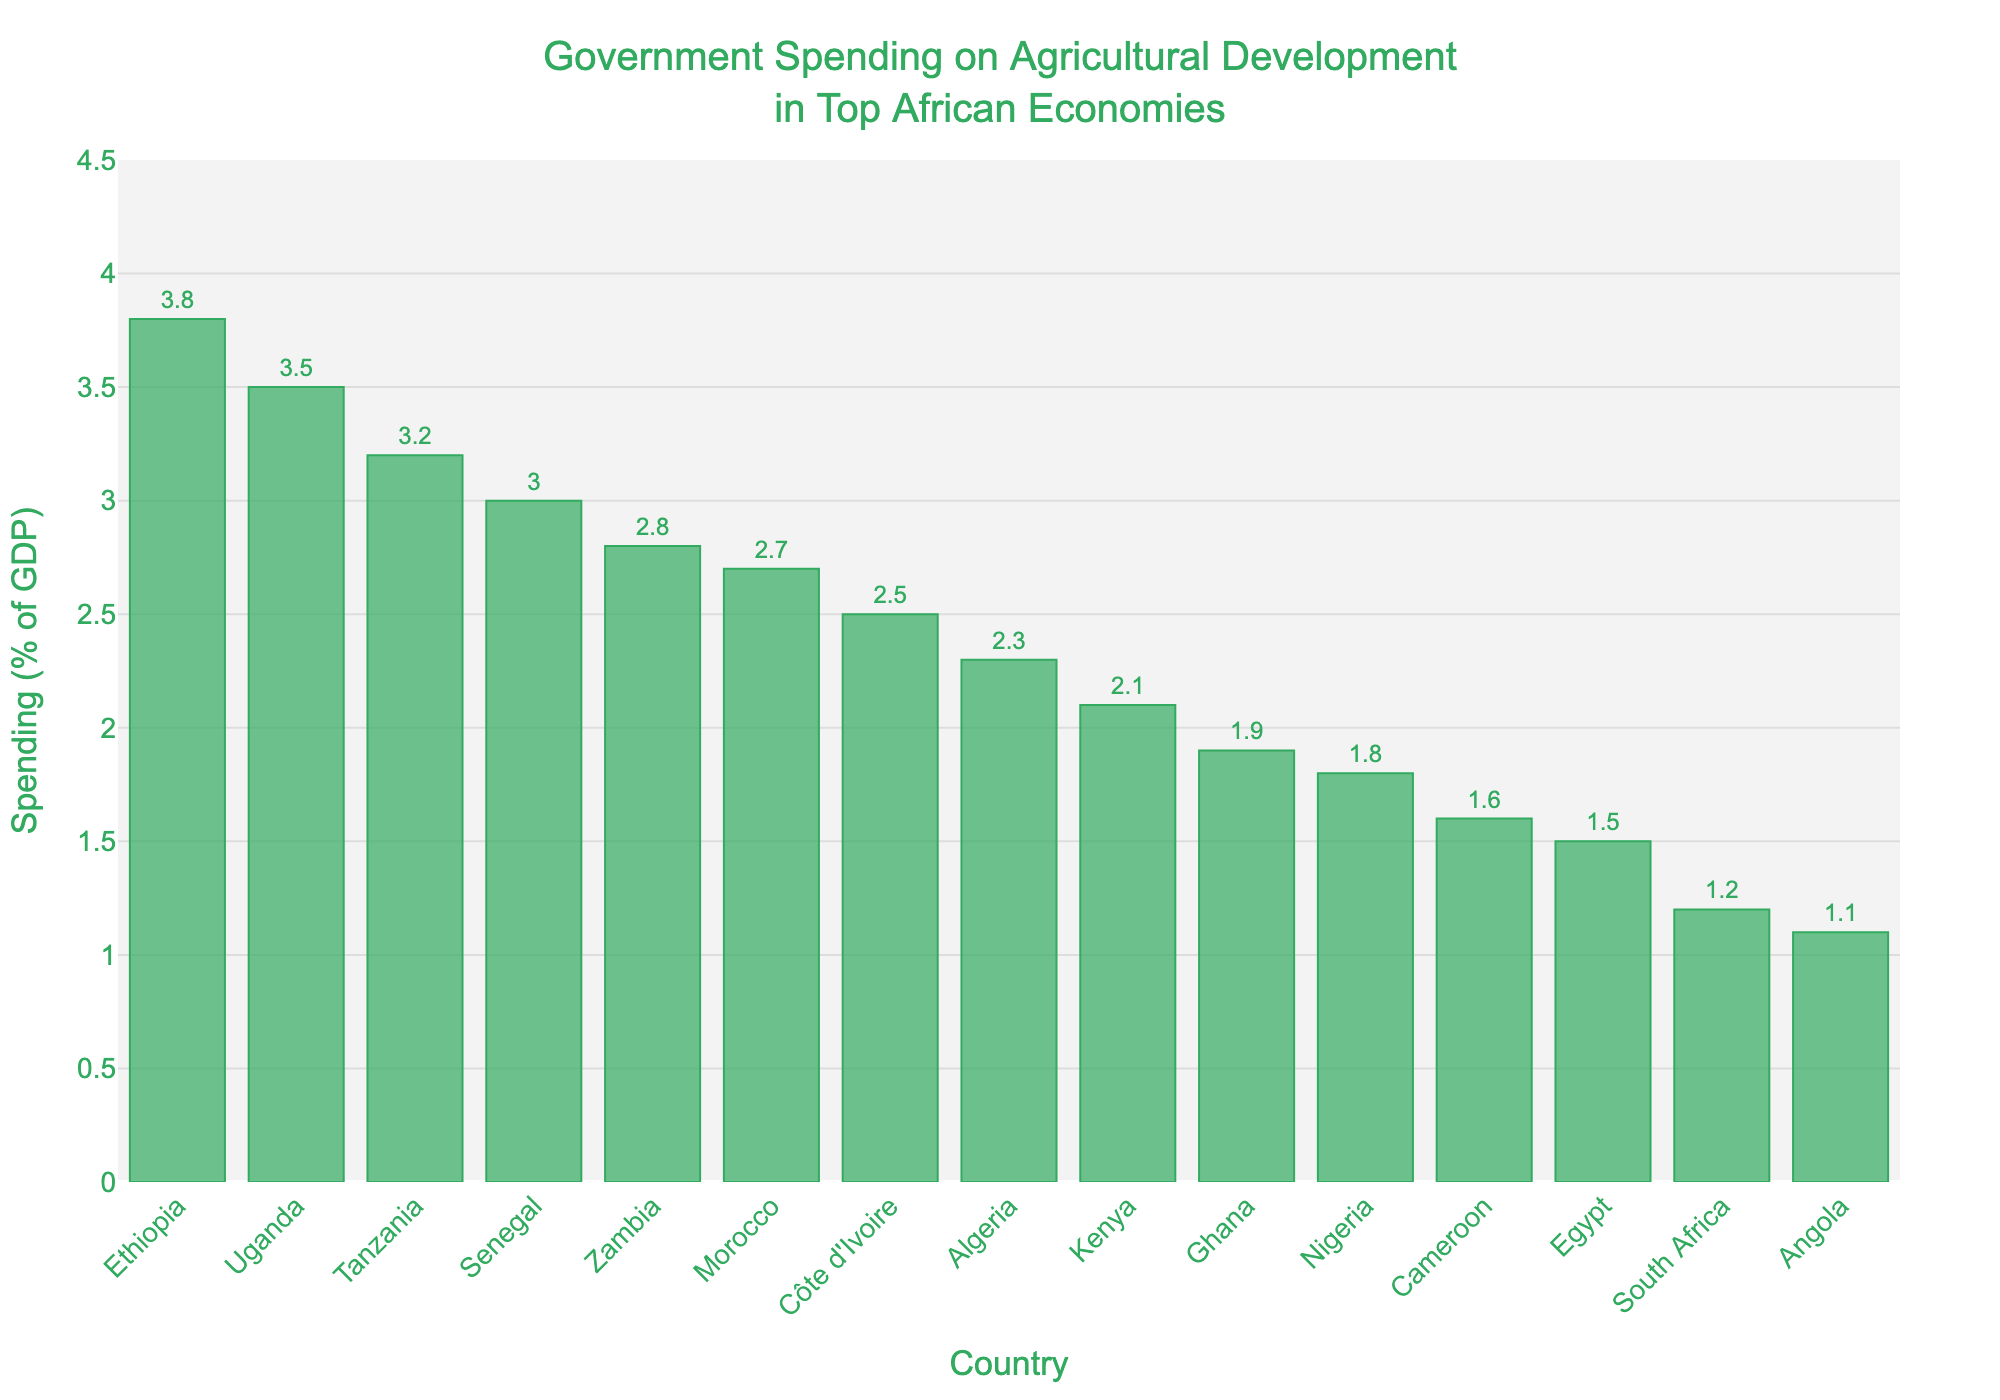Which country has the highest government spending on agricultural development as a percentage of GDP? Ethiopia has the tallest bar in the chart, indicating the highest percentage of GDP spent on agricultural development.
Answer: Ethiopia Which country spends the least on agricultural development as a percentage of GDP? Angola has the shortest bar, indicating the lowest percentage of GDP spent on agricultural development.
Answer: Angola By how much does Ethiopia's spending exceed that of Nigeria? Ethiopia's spending is 3.8% and Nigeria's is 1.8%. The difference is 3.8% - 1.8%.
Answer: 2.0% What is the average government spending on agricultural development for the countries shown? Sum all percentages (1.8 + 1.2 + 1.5 + 2.3 + 2.7 + 2.1 + 3.8 + 1.9 + 3.2 + 2.5 + 3.5 + 1.6 + 2.8 + 1.1 + 3.0) = 35.9. Divide by the number of countries: 35.9 / 15.
Answer: 2.39% How many countries have a government spending of at least 3% of GDP on agricultural development? Countries with spending >= 3% are Ethiopia, Tanzania, Uganda, Senegal. Count these countries.
Answer: 4 Which country spends more on agricultural development: Kenya or Côte d'Ivoire? Compare the heights of the bars for Kenya (2.1%) and Côte d'Ivoire (2.5%). Côte d'Ivoire has a higher bar.
Answer: Côte d'Ivoire What is the median value of government spending on agricultural development across these countries? Arrange the values in ascending order: 1.1, 1.2, 1.5, 1.6, 1.8, 1.9, 2.1, 2.3, 2.5, 2.7, 2.8, 3.0, 3.2, 3.5, 3.8. The middle value (8th in a list of 15) is 2.3.
Answer: 2.3% What is the combined government spending on agricultural development for South Africa and Egypt? Sum the percentages for South Africa (1.2%) and Egypt (1.5%).
Answer: 2.7% How does Zambia's spending compare to Morocco's? Compare Zambia's spending (2.8%) with Morocco's (2.7%). Zambia's percentage is slightly higher.
Answer: Zambia spends more What range of values is covered by the y-axis on the chart? Examine the y-axis labels to see the minimum and maximum values it shows. The y-axis ranges from 0 to 4.5%.
Answer: 0 to 4.5% 